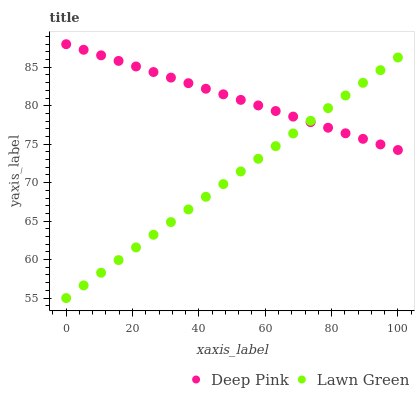Does Lawn Green have the minimum area under the curve?
Answer yes or no. Yes. Does Deep Pink have the maximum area under the curve?
Answer yes or no. Yes. Does Deep Pink have the minimum area under the curve?
Answer yes or no. No. Is Lawn Green the smoothest?
Answer yes or no. Yes. Is Deep Pink the roughest?
Answer yes or no. Yes. Is Deep Pink the smoothest?
Answer yes or no. No. Does Lawn Green have the lowest value?
Answer yes or no. Yes. Does Deep Pink have the lowest value?
Answer yes or no. No. Does Deep Pink have the highest value?
Answer yes or no. Yes. Does Lawn Green intersect Deep Pink?
Answer yes or no. Yes. Is Lawn Green less than Deep Pink?
Answer yes or no. No. Is Lawn Green greater than Deep Pink?
Answer yes or no. No. 